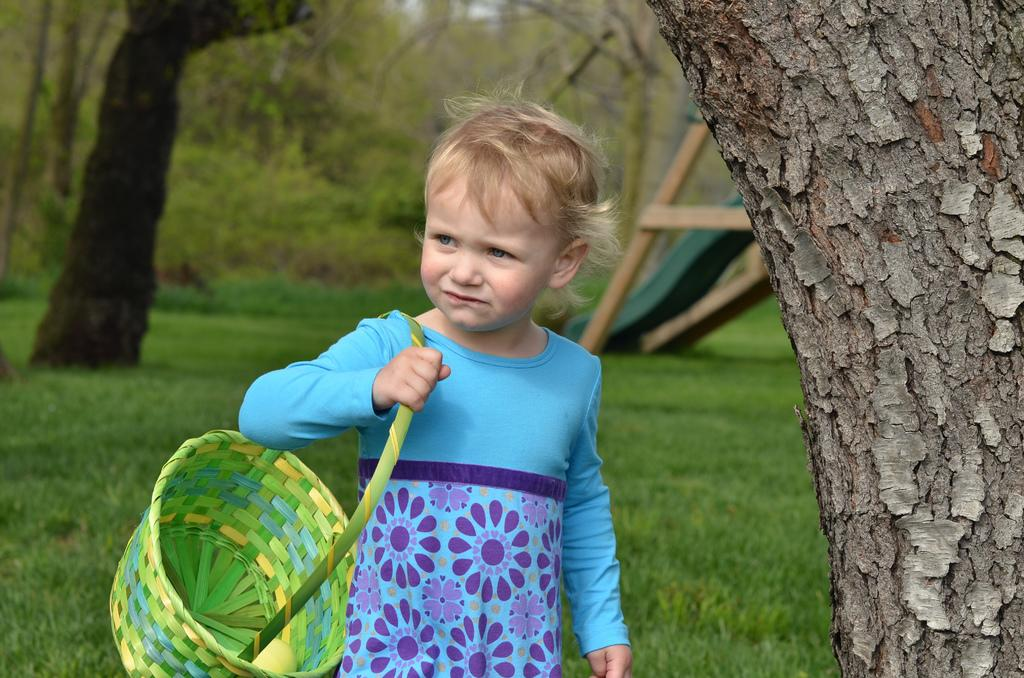What is the main subject of the image? The main subject of the image is a kid. What is the kid wearing? The kid is wearing a blue top. What is the kid holding in the image? The kid is holding a basket on their shoulder. What type of terrain is the kid walking on? The kid is walking on green land. What is located beside the kid? There is a tree beside the kid. What can be seen in the background of the image? Trees are visible in the background of the image. Absurd Question/Answer: What type of vegetable is the kid holding in the basket? There is no indication of the contents of the basket in the image, so it cannot be determined what type of vegetable the kid might be holding. --- Facts: 1. There is a car in the image. 2. The car is red. 3. The car has four wheels. 4. There are people in the car. 5. The car is parked on the street. 6. There are buildings visible in the background of the image. Absurd Topics: parrot, sand, umbrella Conversation: What is the main subject of the image? The main subject of the image is a car. What color is the car? The car is red. How many wheels does the car have? The car has four wheels. Who is inside the car? There are people in the car. Where is the car located? The car is parked on the street. What can be seen in the background of the image? Buildings are visible in the background of the image. Can you tell me how many parrots are sitting on the car's roof in the image? There are no parrots present on the car's roof in the image. What type of sand can be seen on the car's dashboard in the image? There is no sand visible on the car's dashboard in the image. 